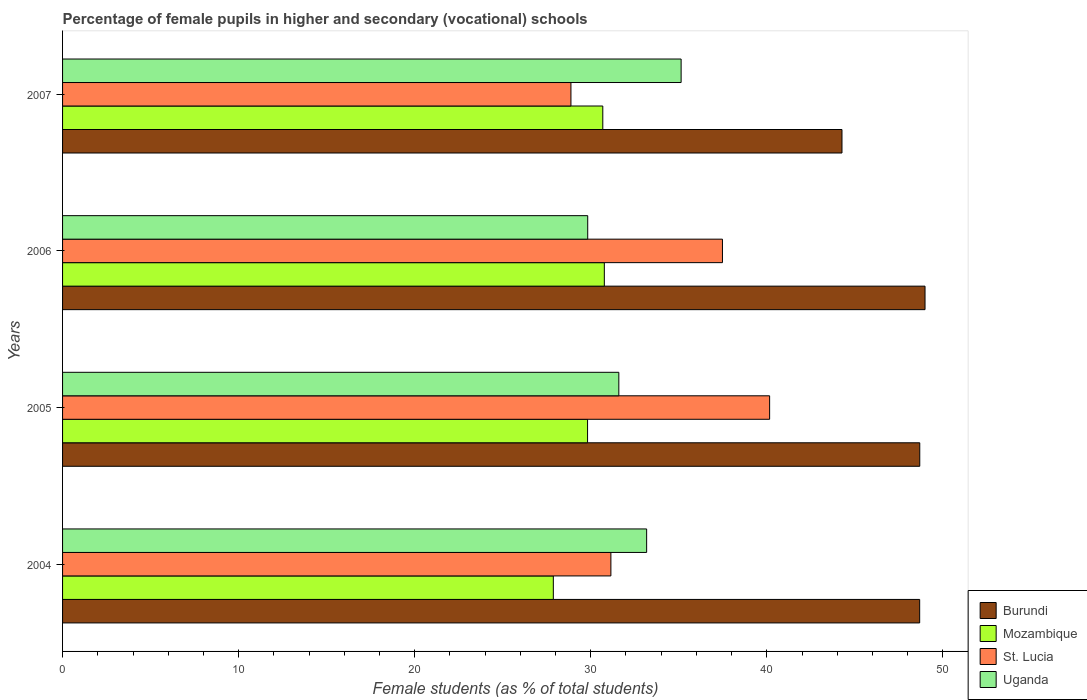How many groups of bars are there?
Give a very brief answer. 4. Are the number of bars per tick equal to the number of legend labels?
Give a very brief answer. Yes. Are the number of bars on each tick of the Y-axis equal?
Make the answer very short. Yes. In how many cases, is the number of bars for a given year not equal to the number of legend labels?
Your response must be concise. 0. What is the percentage of female pupils in higher and secondary schools in St. Lucia in 2004?
Ensure brevity in your answer.  31.14. Across all years, what is the maximum percentage of female pupils in higher and secondary schools in Uganda?
Give a very brief answer. 35.13. Across all years, what is the minimum percentage of female pupils in higher and secondary schools in Mozambique?
Provide a succinct answer. 27.87. In which year was the percentage of female pupils in higher and secondary schools in St. Lucia maximum?
Keep it short and to the point. 2005. What is the total percentage of female pupils in higher and secondary schools in Burundi in the graph?
Offer a terse response. 190.62. What is the difference between the percentage of female pupils in higher and secondary schools in St. Lucia in 2006 and that in 2007?
Your response must be concise. 8.61. What is the difference between the percentage of female pupils in higher and secondary schools in St. Lucia in 2005 and the percentage of female pupils in higher and secondary schools in Burundi in 2007?
Your response must be concise. -4.11. What is the average percentage of female pupils in higher and secondary schools in St. Lucia per year?
Give a very brief answer. 34.41. In the year 2007, what is the difference between the percentage of female pupils in higher and secondary schools in St. Lucia and percentage of female pupils in higher and secondary schools in Uganda?
Offer a very short reply. -6.26. What is the ratio of the percentage of female pupils in higher and secondary schools in Mozambique in 2005 to that in 2007?
Offer a very short reply. 0.97. Is the percentage of female pupils in higher and secondary schools in Burundi in 2004 less than that in 2006?
Your answer should be very brief. Yes. What is the difference between the highest and the second highest percentage of female pupils in higher and secondary schools in Uganda?
Offer a terse response. 1.96. What is the difference between the highest and the lowest percentage of female pupils in higher and secondary schools in Burundi?
Offer a terse response. 4.72. Is the sum of the percentage of female pupils in higher and secondary schools in Burundi in 2004 and 2007 greater than the maximum percentage of female pupils in higher and secondary schools in St. Lucia across all years?
Your answer should be compact. Yes. What does the 3rd bar from the top in 2006 represents?
Make the answer very short. Mozambique. What does the 2nd bar from the bottom in 2004 represents?
Provide a short and direct response. Mozambique. Is it the case that in every year, the sum of the percentage of female pupils in higher and secondary schools in Uganda and percentage of female pupils in higher and secondary schools in Burundi is greater than the percentage of female pupils in higher and secondary schools in Mozambique?
Offer a terse response. Yes. How many bars are there?
Provide a succinct answer. 16. Are the values on the major ticks of X-axis written in scientific E-notation?
Give a very brief answer. No. Does the graph contain grids?
Your response must be concise. No. How many legend labels are there?
Keep it short and to the point. 4. What is the title of the graph?
Make the answer very short. Percentage of female pupils in higher and secondary (vocational) schools. Does "American Samoa" appear as one of the legend labels in the graph?
Provide a succinct answer. No. What is the label or title of the X-axis?
Offer a terse response. Female students (as % of total students). What is the label or title of the Y-axis?
Keep it short and to the point. Years. What is the Female students (as % of total students) in Burundi in 2004?
Provide a succinct answer. 48.68. What is the Female students (as % of total students) of Mozambique in 2004?
Provide a short and direct response. 27.87. What is the Female students (as % of total students) in St. Lucia in 2004?
Your answer should be very brief. 31.14. What is the Female students (as % of total students) of Uganda in 2004?
Provide a short and direct response. 33.17. What is the Female students (as % of total students) of Burundi in 2005?
Offer a terse response. 48.69. What is the Female students (as % of total students) of Mozambique in 2005?
Offer a terse response. 29.82. What is the Female students (as % of total students) of St. Lucia in 2005?
Offer a terse response. 40.16. What is the Female students (as % of total students) of Uganda in 2005?
Your answer should be very brief. 31.59. What is the Female students (as % of total students) of Burundi in 2006?
Your response must be concise. 48.98. What is the Female students (as % of total students) of Mozambique in 2006?
Offer a terse response. 30.77. What is the Female students (as % of total students) of St. Lucia in 2006?
Keep it short and to the point. 37.48. What is the Female students (as % of total students) of Uganda in 2006?
Your answer should be very brief. 29.83. What is the Female students (as % of total students) in Burundi in 2007?
Provide a short and direct response. 44.27. What is the Female students (as % of total students) in Mozambique in 2007?
Provide a succinct answer. 30.68. What is the Female students (as % of total students) of St. Lucia in 2007?
Offer a terse response. 28.87. What is the Female students (as % of total students) of Uganda in 2007?
Offer a terse response. 35.13. Across all years, what is the maximum Female students (as % of total students) of Burundi?
Keep it short and to the point. 48.98. Across all years, what is the maximum Female students (as % of total students) of Mozambique?
Provide a short and direct response. 30.77. Across all years, what is the maximum Female students (as % of total students) in St. Lucia?
Your answer should be very brief. 40.16. Across all years, what is the maximum Female students (as % of total students) of Uganda?
Offer a terse response. 35.13. Across all years, what is the minimum Female students (as % of total students) of Burundi?
Your answer should be compact. 44.27. Across all years, what is the minimum Female students (as % of total students) in Mozambique?
Your answer should be compact. 27.87. Across all years, what is the minimum Female students (as % of total students) in St. Lucia?
Your answer should be very brief. 28.87. Across all years, what is the minimum Female students (as % of total students) of Uganda?
Your answer should be very brief. 29.83. What is the total Female students (as % of total students) in Burundi in the graph?
Provide a succinct answer. 190.62. What is the total Female students (as % of total students) in Mozambique in the graph?
Offer a terse response. 119.14. What is the total Female students (as % of total students) of St. Lucia in the graph?
Your response must be concise. 137.65. What is the total Female students (as % of total students) in Uganda in the graph?
Your answer should be very brief. 129.72. What is the difference between the Female students (as % of total students) in Burundi in 2004 and that in 2005?
Offer a terse response. -0.01. What is the difference between the Female students (as % of total students) of Mozambique in 2004 and that in 2005?
Provide a short and direct response. -1.94. What is the difference between the Female students (as % of total students) of St. Lucia in 2004 and that in 2005?
Give a very brief answer. -9.02. What is the difference between the Female students (as % of total students) in Uganda in 2004 and that in 2005?
Offer a very short reply. 1.58. What is the difference between the Female students (as % of total students) in Burundi in 2004 and that in 2006?
Your answer should be compact. -0.3. What is the difference between the Female students (as % of total students) of Mozambique in 2004 and that in 2006?
Make the answer very short. -2.9. What is the difference between the Female students (as % of total students) of St. Lucia in 2004 and that in 2006?
Give a very brief answer. -6.34. What is the difference between the Female students (as % of total students) in Uganda in 2004 and that in 2006?
Provide a short and direct response. 3.35. What is the difference between the Female students (as % of total students) in Burundi in 2004 and that in 2007?
Offer a very short reply. 4.41. What is the difference between the Female students (as % of total students) of Mozambique in 2004 and that in 2007?
Make the answer very short. -2.81. What is the difference between the Female students (as % of total students) in St. Lucia in 2004 and that in 2007?
Your answer should be very brief. 2.27. What is the difference between the Female students (as % of total students) in Uganda in 2004 and that in 2007?
Your response must be concise. -1.96. What is the difference between the Female students (as % of total students) in Burundi in 2005 and that in 2006?
Your answer should be compact. -0.3. What is the difference between the Female students (as % of total students) in Mozambique in 2005 and that in 2006?
Provide a succinct answer. -0.95. What is the difference between the Female students (as % of total students) in St. Lucia in 2005 and that in 2006?
Your response must be concise. 2.68. What is the difference between the Female students (as % of total students) of Uganda in 2005 and that in 2006?
Provide a succinct answer. 1.77. What is the difference between the Female students (as % of total students) of Burundi in 2005 and that in 2007?
Offer a terse response. 4.42. What is the difference between the Female students (as % of total students) of Mozambique in 2005 and that in 2007?
Your response must be concise. -0.87. What is the difference between the Female students (as % of total students) of St. Lucia in 2005 and that in 2007?
Provide a succinct answer. 11.29. What is the difference between the Female students (as % of total students) of Uganda in 2005 and that in 2007?
Keep it short and to the point. -3.54. What is the difference between the Female students (as % of total students) in Burundi in 2006 and that in 2007?
Give a very brief answer. 4.72. What is the difference between the Female students (as % of total students) of Mozambique in 2006 and that in 2007?
Your answer should be compact. 0.09. What is the difference between the Female students (as % of total students) of St. Lucia in 2006 and that in 2007?
Provide a short and direct response. 8.61. What is the difference between the Female students (as % of total students) in Uganda in 2006 and that in 2007?
Give a very brief answer. -5.3. What is the difference between the Female students (as % of total students) of Burundi in 2004 and the Female students (as % of total students) of Mozambique in 2005?
Your answer should be compact. 18.86. What is the difference between the Female students (as % of total students) in Burundi in 2004 and the Female students (as % of total students) in St. Lucia in 2005?
Your answer should be very brief. 8.52. What is the difference between the Female students (as % of total students) in Burundi in 2004 and the Female students (as % of total students) in Uganda in 2005?
Provide a succinct answer. 17.09. What is the difference between the Female students (as % of total students) in Mozambique in 2004 and the Female students (as % of total students) in St. Lucia in 2005?
Your answer should be very brief. -12.28. What is the difference between the Female students (as % of total students) of Mozambique in 2004 and the Female students (as % of total students) of Uganda in 2005?
Offer a terse response. -3.72. What is the difference between the Female students (as % of total students) of St. Lucia in 2004 and the Female students (as % of total students) of Uganda in 2005?
Provide a short and direct response. -0.45. What is the difference between the Female students (as % of total students) of Burundi in 2004 and the Female students (as % of total students) of Mozambique in 2006?
Your response must be concise. 17.91. What is the difference between the Female students (as % of total students) of Burundi in 2004 and the Female students (as % of total students) of St. Lucia in 2006?
Your answer should be compact. 11.2. What is the difference between the Female students (as % of total students) of Burundi in 2004 and the Female students (as % of total students) of Uganda in 2006?
Ensure brevity in your answer.  18.85. What is the difference between the Female students (as % of total students) of Mozambique in 2004 and the Female students (as % of total students) of St. Lucia in 2006?
Keep it short and to the point. -9.61. What is the difference between the Female students (as % of total students) in Mozambique in 2004 and the Female students (as % of total students) in Uganda in 2006?
Provide a succinct answer. -1.95. What is the difference between the Female students (as % of total students) in St. Lucia in 2004 and the Female students (as % of total students) in Uganda in 2006?
Keep it short and to the point. 1.32. What is the difference between the Female students (as % of total students) in Burundi in 2004 and the Female students (as % of total students) in Mozambique in 2007?
Keep it short and to the point. 18. What is the difference between the Female students (as % of total students) of Burundi in 2004 and the Female students (as % of total students) of St. Lucia in 2007?
Ensure brevity in your answer.  19.81. What is the difference between the Female students (as % of total students) of Burundi in 2004 and the Female students (as % of total students) of Uganda in 2007?
Provide a short and direct response. 13.55. What is the difference between the Female students (as % of total students) in Mozambique in 2004 and the Female students (as % of total students) in St. Lucia in 2007?
Your answer should be compact. -1. What is the difference between the Female students (as % of total students) of Mozambique in 2004 and the Female students (as % of total students) of Uganda in 2007?
Ensure brevity in your answer.  -7.26. What is the difference between the Female students (as % of total students) of St. Lucia in 2004 and the Female students (as % of total students) of Uganda in 2007?
Provide a succinct answer. -3.99. What is the difference between the Female students (as % of total students) in Burundi in 2005 and the Female students (as % of total students) in Mozambique in 2006?
Provide a succinct answer. 17.92. What is the difference between the Female students (as % of total students) in Burundi in 2005 and the Female students (as % of total students) in St. Lucia in 2006?
Provide a short and direct response. 11.21. What is the difference between the Female students (as % of total students) of Burundi in 2005 and the Female students (as % of total students) of Uganda in 2006?
Your response must be concise. 18.86. What is the difference between the Female students (as % of total students) in Mozambique in 2005 and the Female students (as % of total students) in St. Lucia in 2006?
Your response must be concise. -7.66. What is the difference between the Female students (as % of total students) in Mozambique in 2005 and the Female students (as % of total students) in Uganda in 2006?
Offer a terse response. -0.01. What is the difference between the Female students (as % of total students) of St. Lucia in 2005 and the Female students (as % of total students) of Uganda in 2006?
Offer a terse response. 10.33. What is the difference between the Female students (as % of total students) of Burundi in 2005 and the Female students (as % of total students) of Mozambique in 2007?
Ensure brevity in your answer.  18. What is the difference between the Female students (as % of total students) in Burundi in 2005 and the Female students (as % of total students) in St. Lucia in 2007?
Offer a terse response. 19.81. What is the difference between the Female students (as % of total students) of Burundi in 2005 and the Female students (as % of total students) of Uganda in 2007?
Give a very brief answer. 13.55. What is the difference between the Female students (as % of total students) in Mozambique in 2005 and the Female students (as % of total students) in St. Lucia in 2007?
Your answer should be very brief. 0.94. What is the difference between the Female students (as % of total students) of Mozambique in 2005 and the Female students (as % of total students) of Uganda in 2007?
Give a very brief answer. -5.31. What is the difference between the Female students (as % of total students) in St. Lucia in 2005 and the Female students (as % of total students) in Uganda in 2007?
Offer a terse response. 5.03. What is the difference between the Female students (as % of total students) of Burundi in 2006 and the Female students (as % of total students) of Mozambique in 2007?
Give a very brief answer. 18.3. What is the difference between the Female students (as % of total students) of Burundi in 2006 and the Female students (as % of total students) of St. Lucia in 2007?
Give a very brief answer. 20.11. What is the difference between the Female students (as % of total students) of Burundi in 2006 and the Female students (as % of total students) of Uganda in 2007?
Your response must be concise. 13.85. What is the difference between the Female students (as % of total students) in Mozambique in 2006 and the Female students (as % of total students) in St. Lucia in 2007?
Your answer should be compact. 1.9. What is the difference between the Female students (as % of total students) in Mozambique in 2006 and the Female students (as % of total students) in Uganda in 2007?
Provide a succinct answer. -4.36. What is the difference between the Female students (as % of total students) in St. Lucia in 2006 and the Female students (as % of total students) in Uganda in 2007?
Make the answer very short. 2.35. What is the average Female students (as % of total students) in Burundi per year?
Your answer should be very brief. 47.65. What is the average Female students (as % of total students) in Mozambique per year?
Offer a very short reply. 29.79. What is the average Female students (as % of total students) of St. Lucia per year?
Give a very brief answer. 34.41. What is the average Female students (as % of total students) of Uganda per year?
Make the answer very short. 32.43. In the year 2004, what is the difference between the Female students (as % of total students) of Burundi and Female students (as % of total students) of Mozambique?
Provide a short and direct response. 20.81. In the year 2004, what is the difference between the Female students (as % of total students) of Burundi and Female students (as % of total students) of St. Lucia?
Offer a very short reply. 17.54. In the year 2004, what is the difference between the Female students (as % of total students) of Burundi and Female students (as % of total students) of Uganda?
Ensure brevity in your answer.  15.51. In the year 2004, what is the difference between the Female students (as % of total students) of Mozambique and Female students (as % of total students) of St. Lucia?
Offer a terse response. -3.27. In the year 2004, what is the difference between the Female students (as % of total students) of Mozambique and Female students (as % of total students) of Uganda?
Offer a terse response. -5.3. In the year 2004, what is the difference between the Female students (as % of total students) of St. Lucia and Female students (as % of total students) of Uganda?
Give a very brief answer. -2.03. In the year 2005, what is the difference between the Female students (as % of total students) of Burundi and Female students (as % of total students) of Mozambique?
Provide a succinct answer. 18.87. In the year 2005, what is the difference between the Female students (as % of total students) of Burundi and Female students (as % of total students) of St. Lucia?
Give a very brief answer. 8.53. In the year 2005, what is the difference between the Female students (as % of total students) in Burundi and Female students (as % of total students) in Uganda?
Your response must be concise. 17.09. In the year 2005, what is the difference between the Female students (as % of total students) in Mozambique and Female students (as % of total students) in St. Lucia?
Your answer should be very brief. -10.34. In the year 2005, what is the difference between the Female students (as % of total students) in Mozambique and Female students (as % of total students) in Uganda?
Make the answer very short. -1.78. In the year 2005, what is the difference between the Female students (as % of total students) in St. Lucia and Female students (as % of total students) in Uganda?
Your answer should be compact. 8.57. In the year 2006, what is the difference between the Female students (as % of total students) in Burundi and Female students (as % of total students) in Mozambique?
Offer a terse response. 18.21. In the year 2006, what is the difference between the Female students (as % of total students) of Burundi and Female students (as % of total students) of St. Lucia?
Provide a succinct answer. 11.5. In the year 2006, what is the difference between the Female students (as % of total students) in Burundi and Female students (as % of total students) in Uganda?
Your answer should be compact. 19.16. In the year 2006, what is the difference between the Female students (as % of total students) of Mozambique and Female students (as % of total students) of St. Lucia?
Offer a very short reply. -6.71. In the year 2006, what is the difference between the Female students (as % of total students) of Mozambique and Female students (as % of total students) of Uganda?
Your answer should be very brief. 0.94. In the year 2006, what is the difference between the Female students (as % of total students) in St. Lucia and Female students (as % of total students) in Uganda?
Provide a succinct answer. 7.65. In the year 2007, what is the difference between the Female students (as % of total students) of Burundi and Female students (as % of total students) of Mozambique?
Offer a terse response. 13.58. In the year 2007, what is the difference between the Female students (as % of total students) of Burundi and Female students (as % of total students) of St. Lucia?
Ensure brevity in your answer.  15.39. In the year 2007, what is the difference between the Female students (as % of total students) in Burundi and Female students (as % of total students) in Uganda?
Your answer should be very brief. 9.14. In the year 2007, what is the difference between the Female students (as % of total students) in Mozambique and Female students (as % of total students) in St. Lucia?
Provide a short and direct response. 1.81. In the year 2007, what is the difference between the Female students (as % of total students) of Mozambique and Female students (as % of total students) of Uganda?
Your answer should be very brief. -4.45. In the year 2007, what is the difference between the Female students (as % of total students) in St. Lucia and Female students (as % of total students) in Uganda?
Provide a succinct answer. -6.26. What is the ratio of the Female students (as % of total students) of Burundi in 2004 to that in 2005?
Your answer should be very brief. 1. What is the ratio of the Female students (as % of total students) of Mozambique in 2004 to that in 2005?
Make the answer very short. 0.93. What is the ratio of the Female students (as % of total students) of St. Lucia in 2004 to that in 2005?
Offer a very short reply. 0.78. What is the ratio of the Female students (as % of total students) of Uganda in 2004 to that in 2005?
Your answer should be very brief. 1.05. What is the ratio of the Female students (as % of total students) of Mozambique in 2004 to that in 2006?
Offer a very short reply. 0.91. What is the ratio of the Female students (as % of total students) in St. Lucia in 2004 to that in 2006?
Ensure brevity in your answer.  0.83. What is the ratio of the Female students (as % of total students) in Uganda in 2004 to that in 2006?
Your response must be concise. 1.11. What is the ratio of the Female students (as % of total students) of Burundi in 2004 to that in 2007?
Ensure brevity in your answer.  1.1. What is the ratio of the Female students (as % of total students) in Mozambique in 2004 to that in 2007?
Your response must be concise. 0.91. What is the ratio of the Female students (as % of total students) in St. Lucia in 2004 to that in 2007?
Offer a very short reply. 1.08. What is the ratio of the Female students (as % of total students) in Uganda in 2004 to that in 2007?
Make the answer very short. 0.94. What is the ratio of the Female students (as % of total students) in St. Lucia in 2005 to that in 2006?
Your answer should be compact. 1.07. What is the ratio of the Female students (as % of total students) in Uganda in 2005 to that in 2006?
Offer a terse response. 1.06. What is the ratio of the Female students (as % of total students) of Burundi in 2005 to that in 2007?
Make the answer very short. 1.1. What is the ratio of the Female students (as % of total students) in Mozambique in 2005 to that in 2007?
Ensure brevity in your answer.  0.97. What is the ratio of the Female students (as % of total students) in St. Lucia in 2005 to that in 2007?
Your answer should be compact. 1.39. What is the ratio of the Female students (as % of total students) in Uganda in 2005 to that in 2007?
Make the answer very short. 0.9. What is the ratio of the Female students (as % of total students) in Burundi in 2006 to that in 2007?
Provide a succinct answer. 1.11. What is the ratio of the Female students (as % of total students) in St. Lucia in 2006 to that in 2007?
Make the answer very short. 1.3. What is the ratio of the Female students (as % of total students) in Uganda in 2006 to that in 2007?
Ensure brevity in your answer.  0.85. What is the difference between the highest and the second highest Female students (as % of total students) in Burundi?
Ensure brevity in your answer.  0.3. What is the difference between the highest and the second highest Female students (as % of total students) of Mozambique?
Give a very brief answer. 0.09. What is the difference between the highest and the second highest Female students (as % of total students) in St. Lucia?
Give a very brief answer. 2.68. What is the difference between the highest and the second highest Female students (as % of total students) of Uganda?
Offer a very short reply. 1.96. What is the difference between the highest and the lowest Female students (as % of total students) in Burundi?
Your answer should be compact. 4.72. What is the difference between the highest and the lowest Female students (as % of total students) of Mozambique?
Ensure brevity in your answer.  2.9. What is the difference between the highest and the lowest Female students (as % of total students) in St. Lucia?
Offer a terse response. 11.29. What is the difference between the highest and the lowest Female students (as % of total students) of Uganda?
Give a very brief answer. 5.3. 